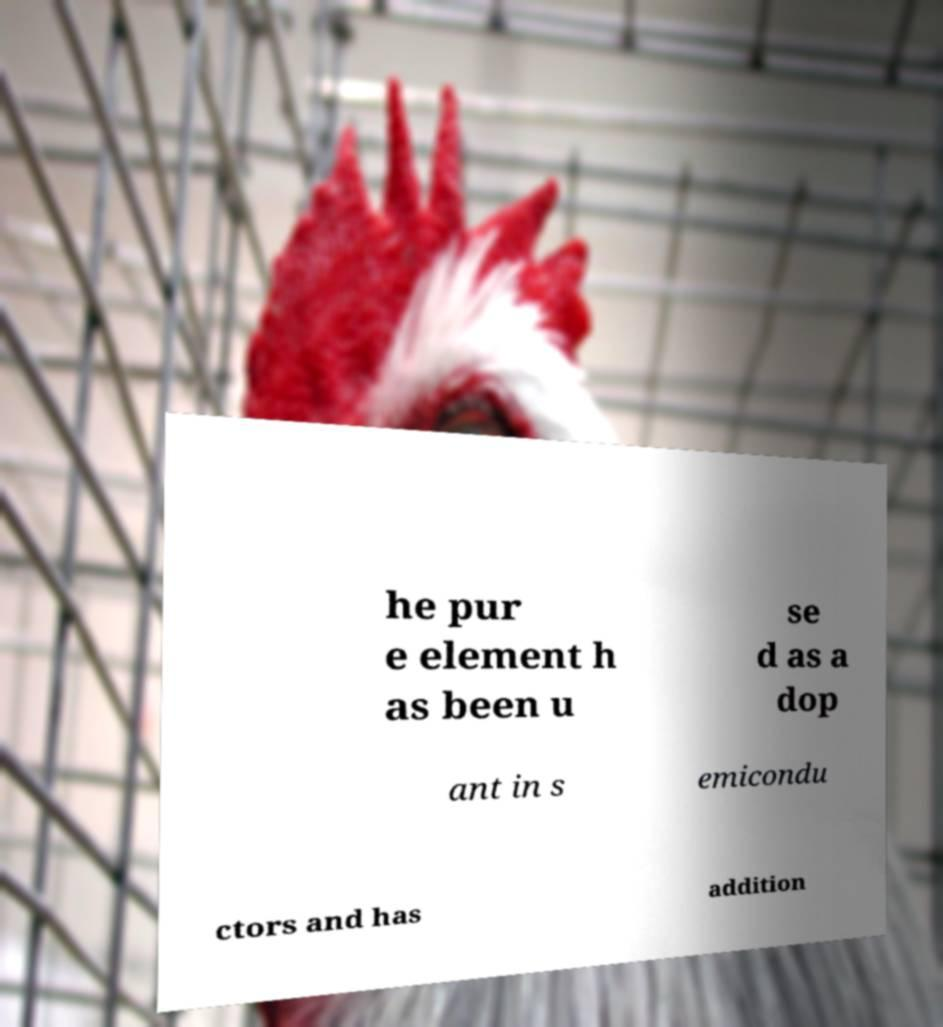What messages or text are displayed in this image? I need them in a readable, typed format. he pur e element h as been u se d as a dop ant in s emicondu ctors and has addition 